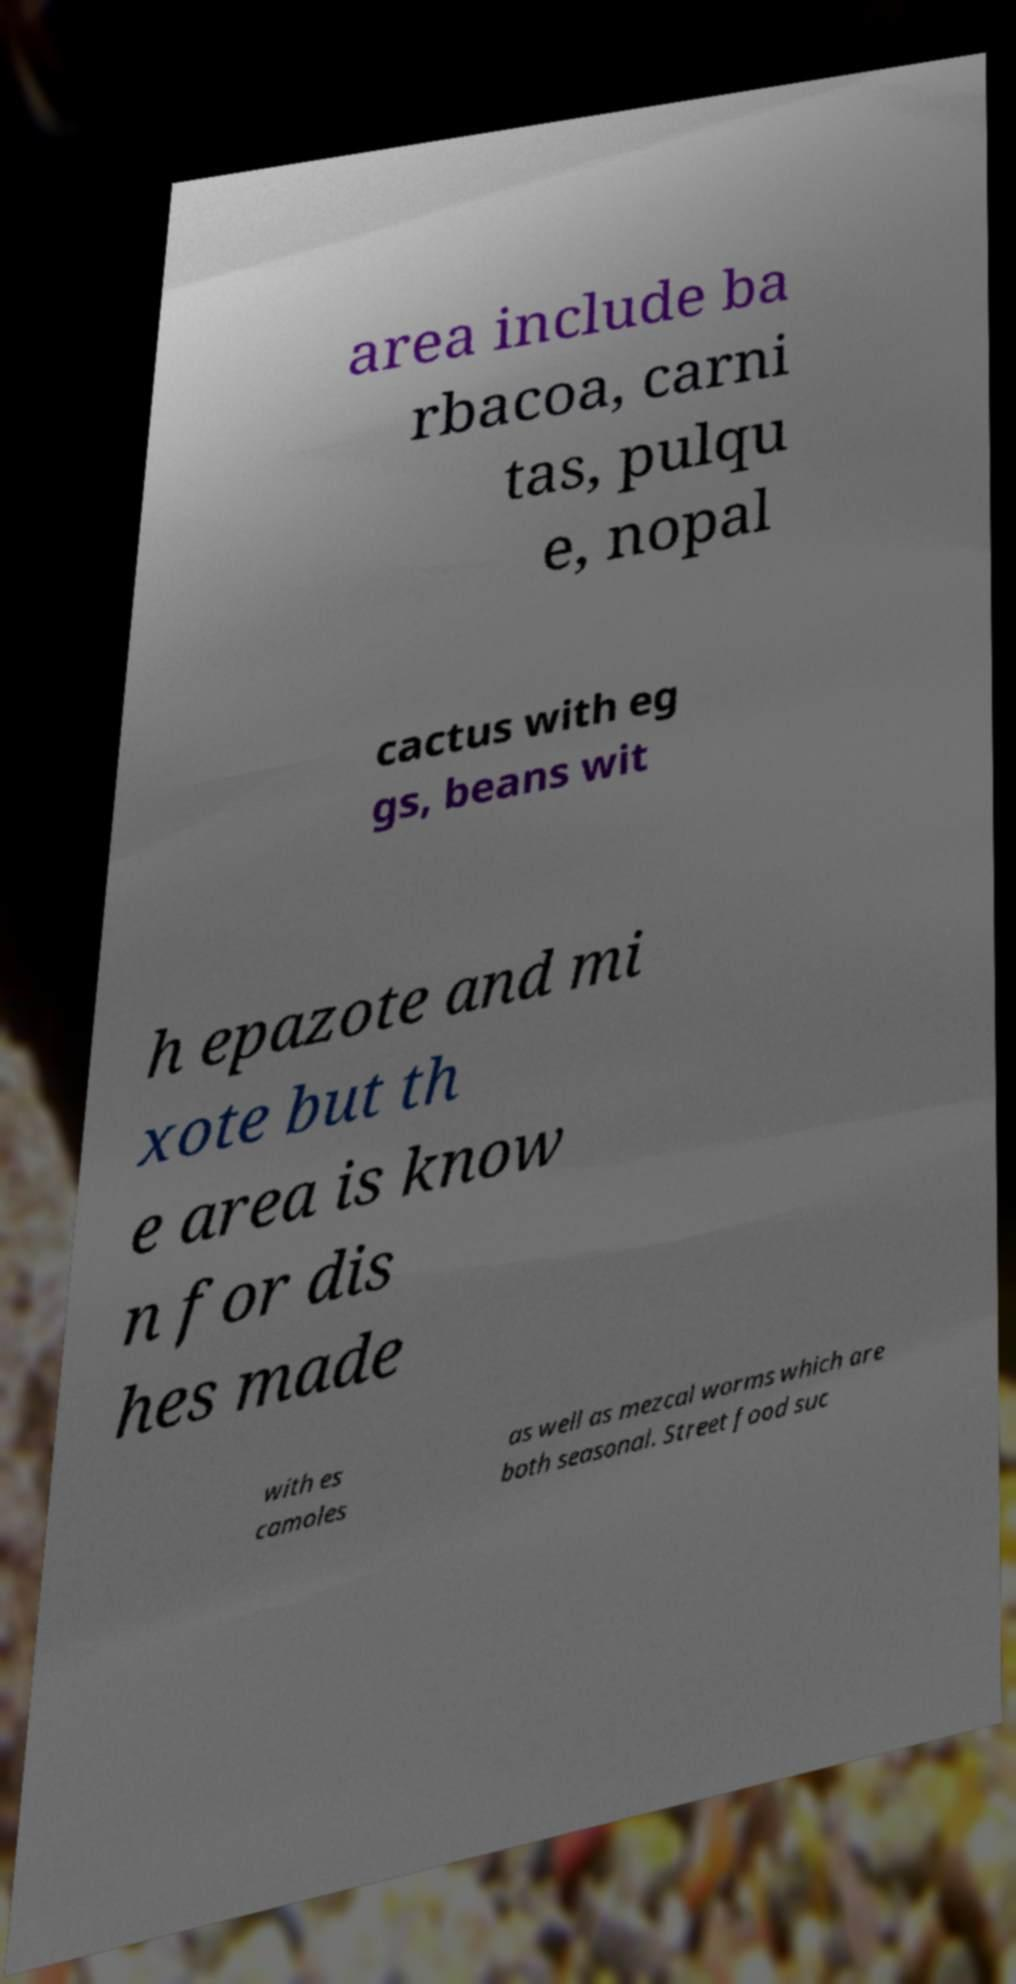Please identify and transcribe the text found in this image. area include ba rbacoa, carni tas, pulqu e, nopal cactus with eg gs, beans wit h epazote and mi xote but th e area is know n for dis hes made with es camoles as well as mezcal worms which are both seasonal. Street food suc 